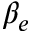<formula> <loc_0><loc_0><loc_500><loc_500>\beta _ { e }</formula> 